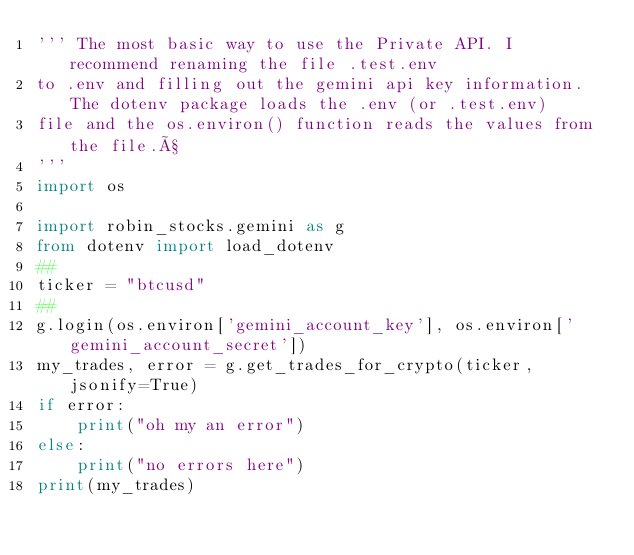Convert code to text. <code><loc_0><loc_0><loc_500><loc_500><_Python_>''' The most basic way to use the Private API. I recommend renaming the file .test.env
to .env and filling out the gemini api key information. The dotenv package loads the .env (or .test.env)
file and the os.environ() function reads the values from the file.ß
'''
import os

import robin_stocks.gemini as g
from dotenv import load_dotenv
##
ticker = "btcusd"
##
g.login(os.environ['gemini_account_key'], os.environ['gemini_account_secret'])
my_trades, error = g.get_trades_for_crypto(ticker, jsonify=True)
if error:
    print("oh my an error")
else:
    print("no errors here")
print(my_trades)
</code> 